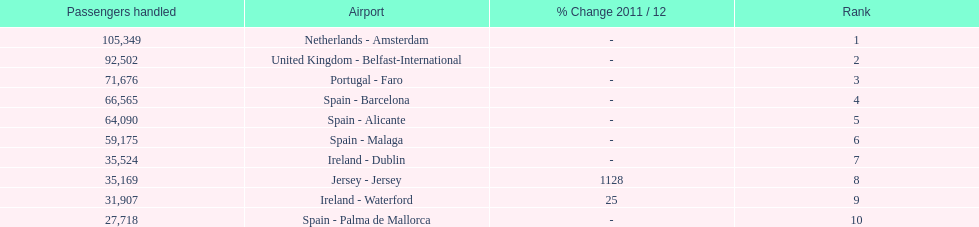How many airports are listed? 10. 